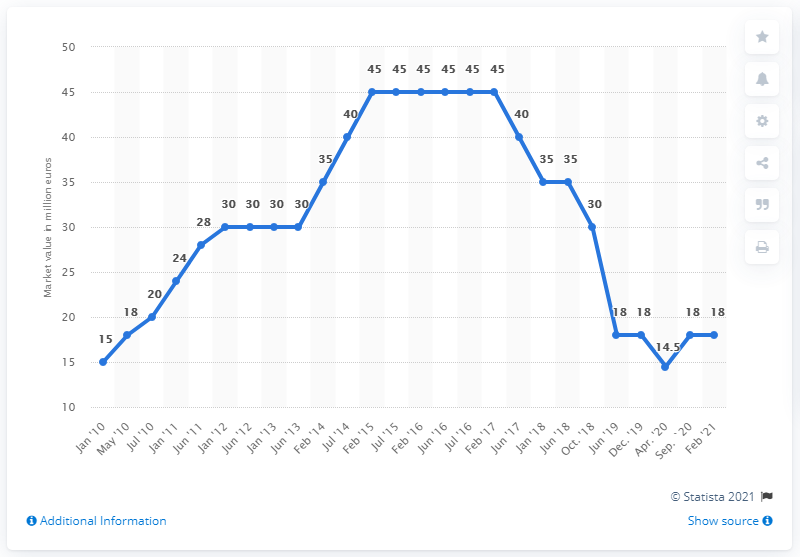Point out several critical features in this image. Manuel Neuer's market value in February 2021 was reported to be 18 million dollars. 